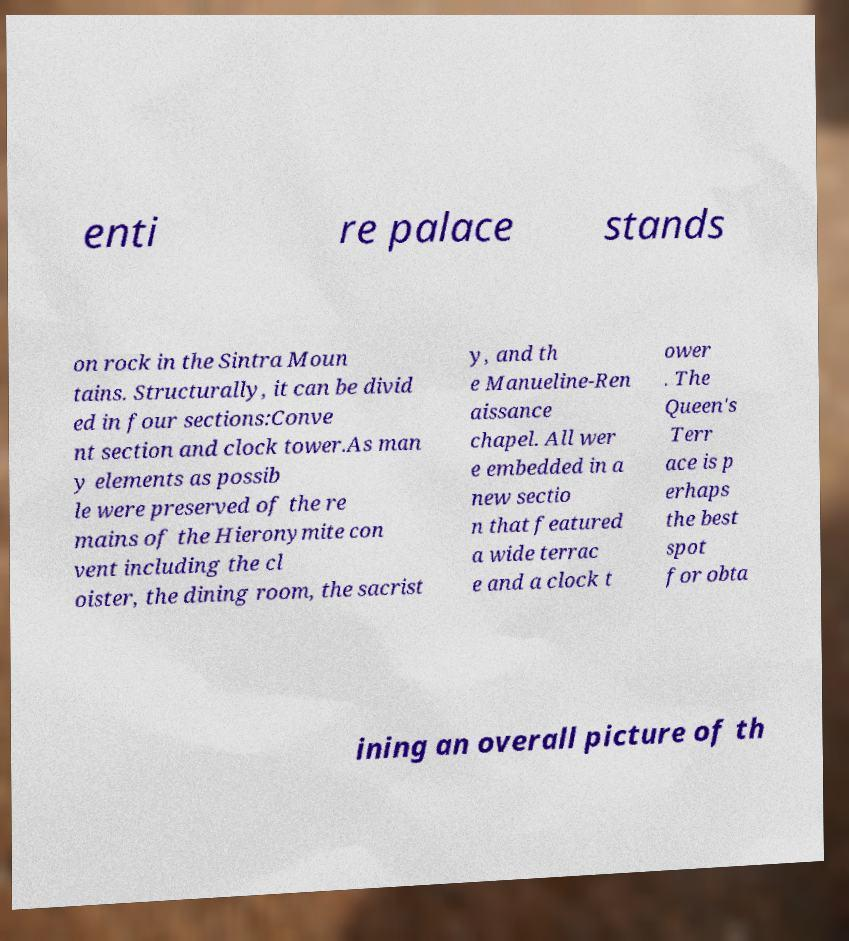What messages or text are displayed in this image? I need them in a readable, typed format. enti re palace stands on rock in the Sintra Moun tains. Structurally, it can be divid ed in four sections:Conve nt section and clock tower.As man y elements as possib le were preserved of the re mains of the Hieronymite con vent including the cl oister, the dining room, the sacrist y, and th e Manueline-Ren aissance chapel. All wer e embedded in a new sectio n that featured a wide terrac e and a clock t ower . The Queen's Terr ace is p erhaps the best spot for obta ining an overall picture of th 